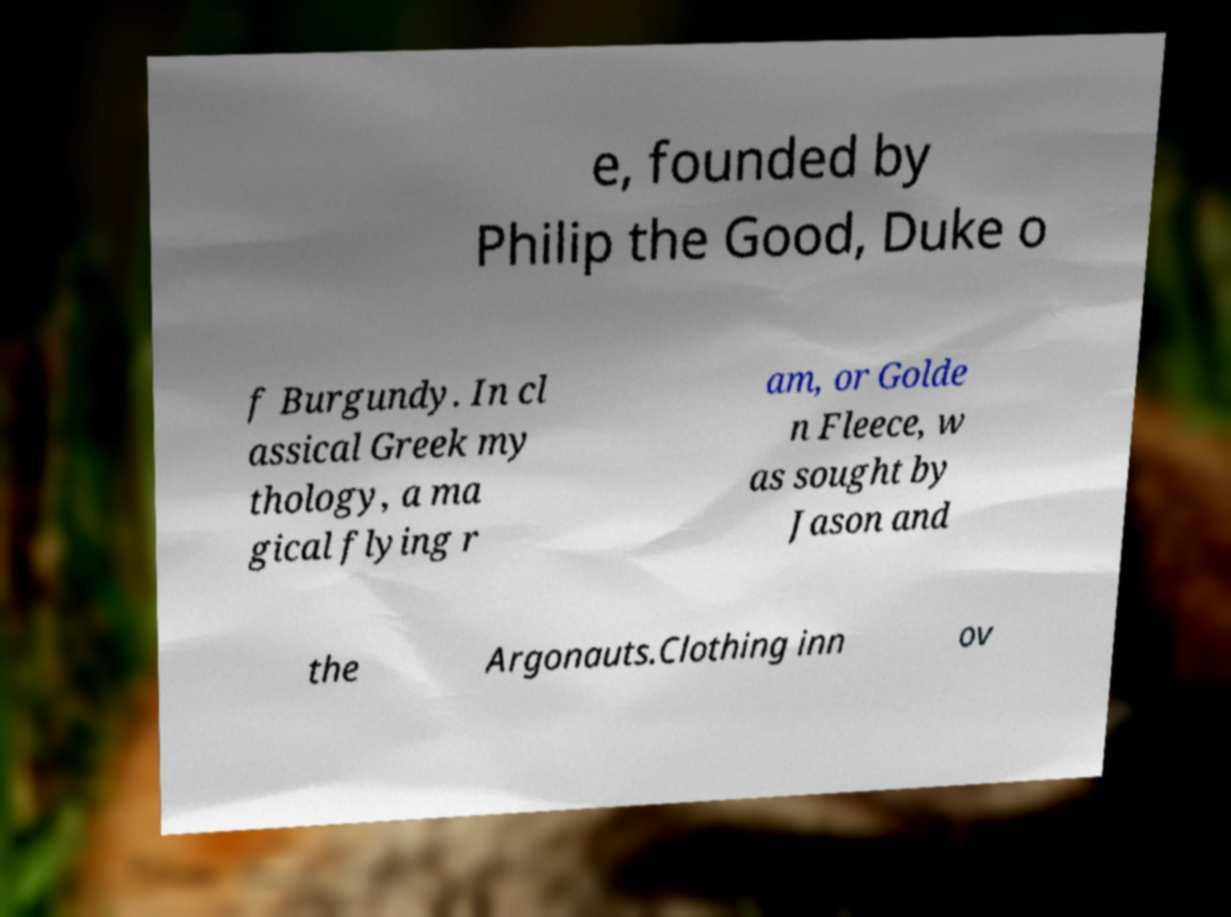Can you accurately transcribe the text from the provided image for me? e, founded by Philip the Good, Duke o f Burgundy. In cl assical Greek my thology, a ma gical flying r am, or Golde n Fleece, w as sought by Jason and the Argonauts.Clothing inn ov 